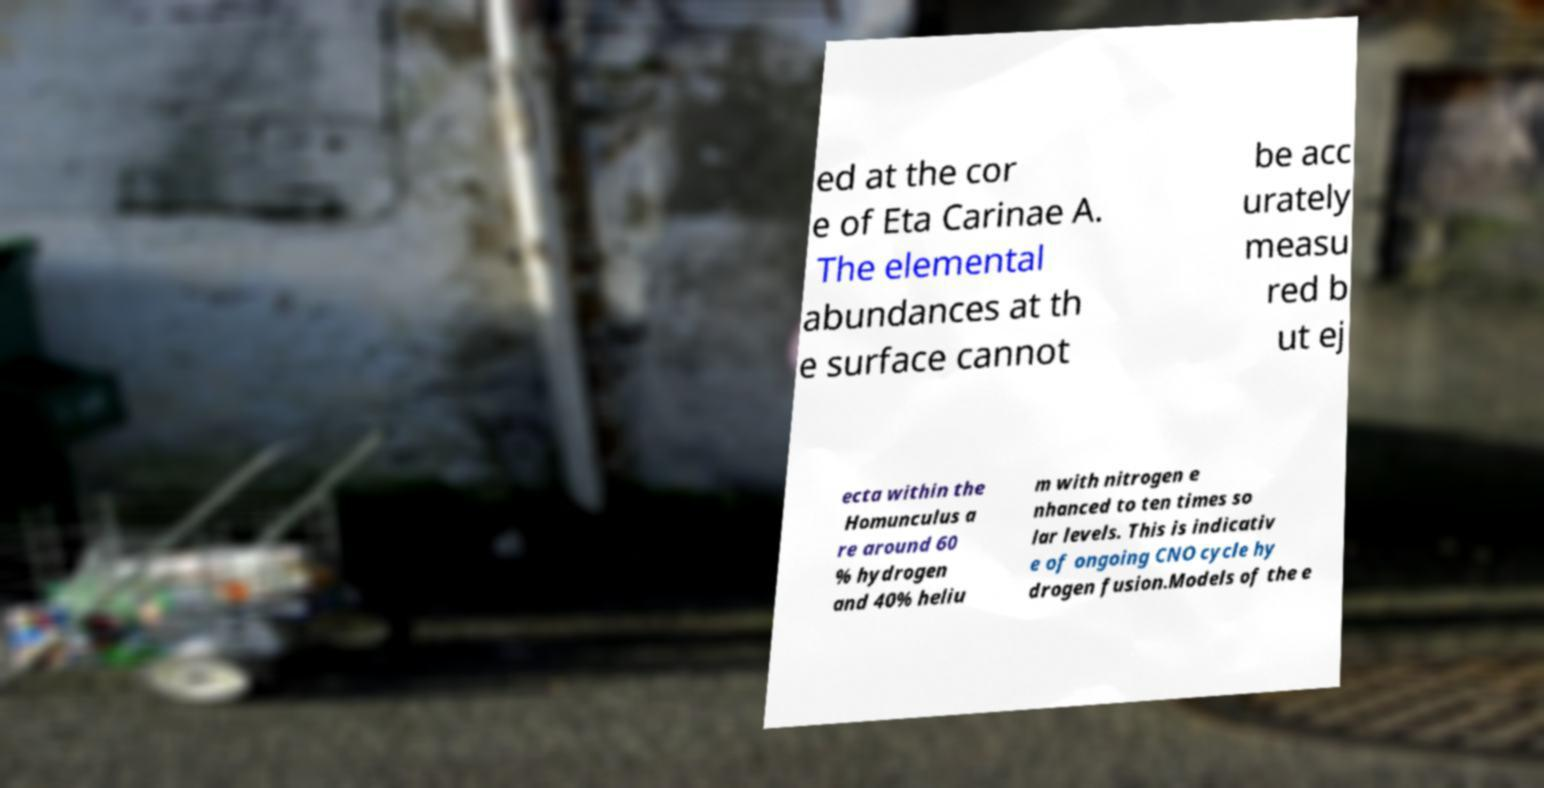Please identify and transcribe the text found in this image. ed at the cor e of Eta Carinae A. The elemental abundances at th e surface cannot be acc urately measu red b ut ej ecta within the Homunculus a re around 60 % hydrogen and 40% heliu m with nitrogen e nhanced to ten times so lar levels. This is indicativ e of ongoing CNO cycle hy drogen fusion.Models of the e 